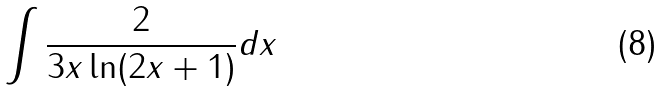<formula> <loc_0><loc_0><loc_500><loc_500>\int \frac { 2 } { 3 x \ln ( 2 x + 1 ) } d x</formula> 